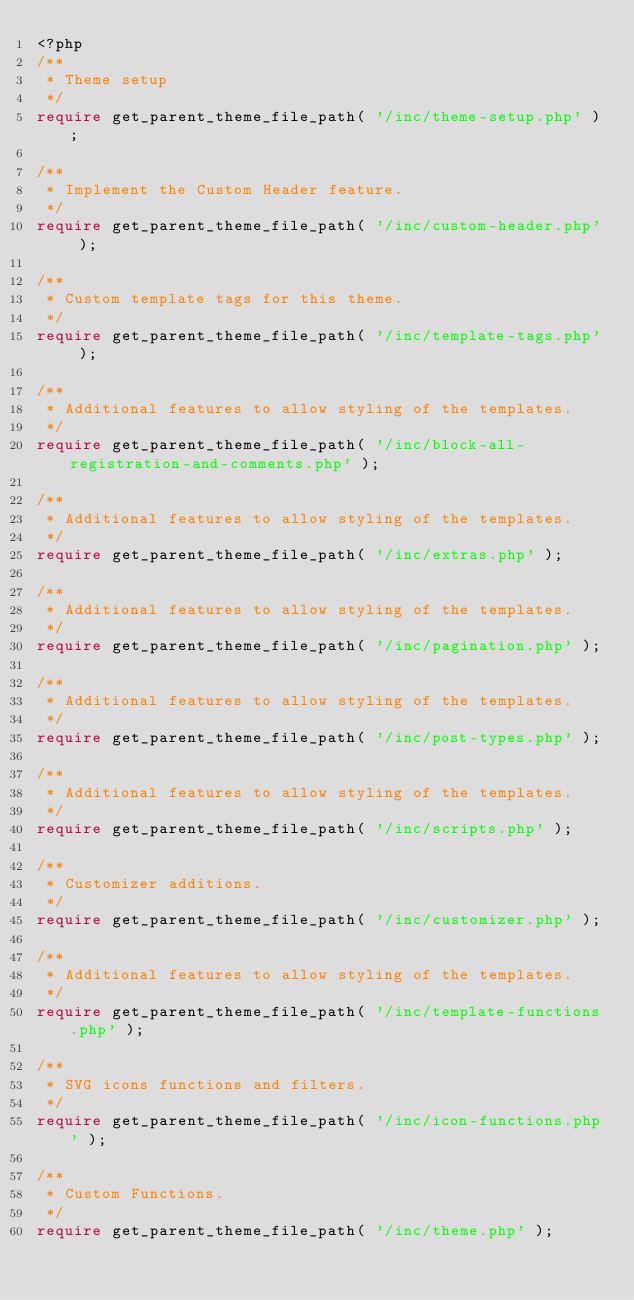Convert code to text. <code><loc_0><loc_0><loc_500><loc_500><_PHP_><?php
/**
 * Theme setup
 */
require get_parent_theme_file_path( '/inc/theme-setup.php' );

/**
 * Implement the Custom Header feature.
 */
require get_parent_theme_file_path( '/inc/custom-header.php' );

/**
 * Custom template tags for this theme.
 */
require get_parent_theme_file_path( '/inc/template-tags.php' );

/**
 * Additional features to allow styling of the templates.
 */
require get_parent_theme_file_path( '/inc/block-all-registration-and-comments.php' );

/**
 * Additional features to allow styling of the templates.
 */
require get_parent_theme_file_path( '/inc/extras.php' );

/**
 * Additional features to allow styling of the templates.
 */
require get_parent_theme_file_path( '/inc/pagination.php' );

/**
 * Additional features to allow styling of the templates.
 */
require get_parent_theme_file_path( '/inc/post-types.php' );

/**
 * Additional features to allow styling of the templates.
 */
require get_parent_theme_file_path( '/inc/scripts.php' );

/**
 * Customizer additions.
 */
require get_parent_theme_file_path( '/inc/customizer.php' );

/**
 * Additional features to allow styling of the templates.
 */
require get_parent_theme_file_path( '/inc/template-functions.php' );

/**
 * SVG icons functions and filters.
 */
require get_parent_theme_file_path( '/inc/icon-functions.php' );

/**
 * Custom Functions.
 */
require get_parent_theme_file_path( '/inc/theme.php' );
</code> 